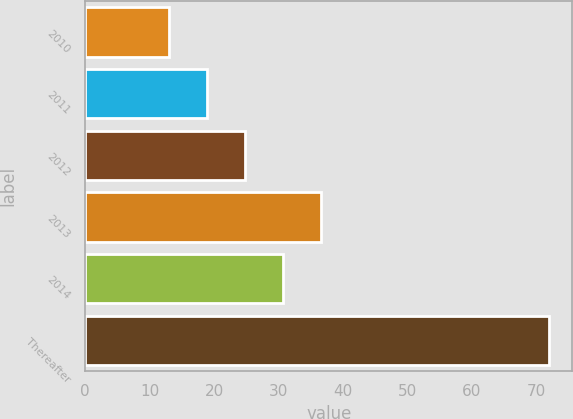Convert chart. <chart><loc_0><loc_0><loc_500><loc_500><bar_chart><fcel>2010<fcel>2011<fcel>2012<fcel>2013<fcel>2014<fcel>Thereafter<nl><fcel>13<fcel>18.9<fcel>24.8<fcel>36.6<fcel>30.7<fcel>72<nl></chart> 